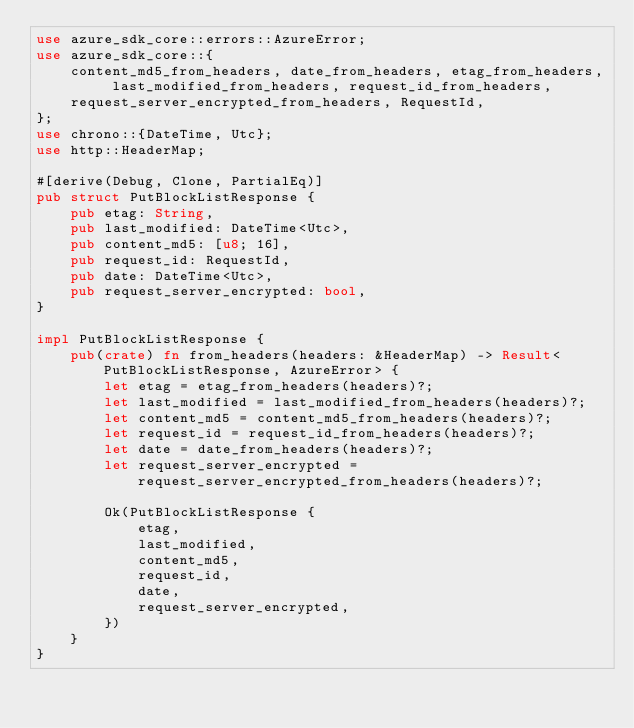<code> <loc_0><loc_0><loc_500><loc_500><_Rust_>use azure_sdk_core::errors::AzureError;
use azure_sdk_core::{
    content_md5_from_headers, date_from_headers, etag_from_headers, last_modified_from_headers, request_id_from_headers,
    request_server_encrypted_from_headers, RequestId,
};
use chrono::{DateTime, Utc};
use http::HeaderMap;

#[derive(Debug, Clone, PartialEq)]
pub struct PutBlockListResponse {
    pub etag: String,
    pub last_modified: DateTime<Utc>,
    pub content_md5: [u8; 16],
    pub request_id: RequestId,
    pub date: DateTime<Utc>,
    pub request_server_encrypted: bool,
}

impl PutBlockListResponse {
    pub(crate) fn from_headers(headers: &HeaderMap) -> Result<PutBlockListResponse, AzureError> {
        let etag = etag_from_headers(headers)?;
        let last_modified = last_modified_from_headers(headers)?;
        let content_md5 = content_md5_from_headers(headers)?;
        let request_id = request_id_from_headers(headers)?;
        let date = date_from_headers(headers)?;
        let request_server_encrypted = request_server_encrypted_from_headers(headers)?;

        Ok(PutBlockListResponse {
            etag,
            last_modified,
            content_md5,
            request_id,
            date,
            request_server_encrypted,
        })
    }
}
</code> 